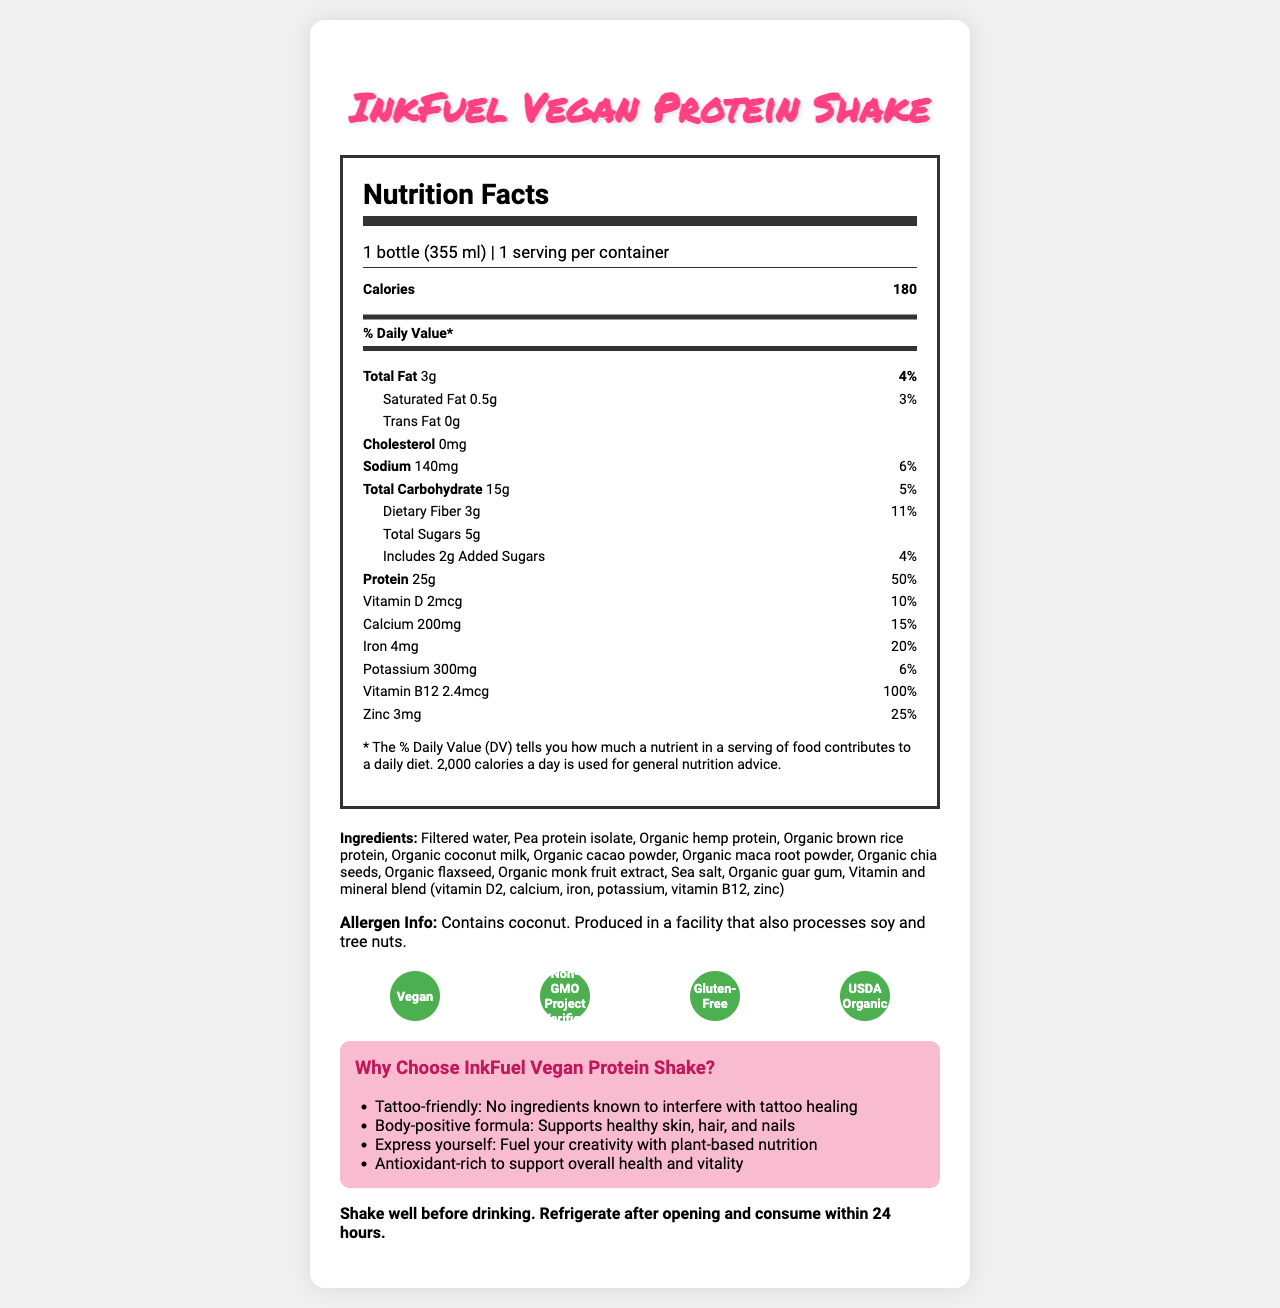what is the serving size? The serving size is specified as "1 bottle (355 ml)" in the document.
Answer: 1 bottle (355 ml) how many calories are in one serving of InkFuel Vegan Protein Shake? The number of calories per serving is listed as "180" in the document.
Answer: 180 which ingredients are included in the InkFuel Vegan Protein Shake? The ingredients section lists all these items as the ingredients in the protein shake.
Answer: Filtered water, Pea protein isolate, Organic hemp protein, Organic brown rice protein, Organic coconut milk, Organic cacao powder, Organic maca root powder, Organic chia seeds, Organic flaxseed, Organic monk fruit extract, Sea salt, Organic guar gum, Vitamin and mineral blend (vitamin D2, calcium, iron, potassium, vitamin B12, zinc) what is the amount of protein in one serving? The document shows that there is "25g" of protein in one serving of the shake.
Answer: 25g what percentage of the daily value does the dietary fiber in the shake cover? The dietary fiber covers 11% of the daily value according to the nutrition facts.
Answer: 11% does the product contain any cholesterol? The document states "Cholesterol: 0mg," indicating there is no cholesterol.
Answer: No what certifications does the InkFuel Vegan Protein Shake have? A. Vegan B. Non-GMO Project Verified C. Gluten-Free D. USDA Organic E. All of the above The product has all these certifications, as listed in the certifications section.
Answer: E why is this product labeled as "Tattoo-friendly"? A. It has ingredients that promote tattoo healing B. It has no ingredients known to interfere with tattoo healing C. It contains ingredients that can be used for tattoo ink The document specifically claims "Tattoo-friendly: No ingredients known to interfere with tattoo healing."
Answer: B what are the packaging features of InkFuel Vegan Protein Shake? The packaging features listed in the document include BPA-free bottle, 100% recyclable packaging, and a vibrant tattoo-inspired label design.
Answer: BPA-free bottle, 100% recyclable packaging, Vibrant tattoo-inspired label design does the InkFuel Vegan Protein Shake contain soy? However, it is produced in a facility that also processes soy and tree nuts, according to the allergen information.
Answer: No does the product contain any added sugars? The document indicates there are "2g" of added sugars.
Answer: Yes describe the main purpose and benefits of InkFuel Vegan Protein Shake as presented in the document The document emphasizes the shake's body-positive formula, its support for healthy skin, hair, and nails, its suitability for those with tattoos, and its contribution to overall health and vitality through plant-based nutrition.
Answer: The main purpose of the InkFuel Vegan Protein Shake is to provide plant-based nutrition that supports body positivity and self-expression. It is tattoo-friendly, supports healthy skin, hair, and nails, and is antioxidant-rich to promote overall health and vitality. can you determine the total revenue generated from the sales of these protein shakes? The document does not provide any information about the sales or revenue generated from this product.
Answer: Cannot be determined 